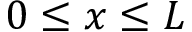<formula> <loc_0><loc_0><loc_500><loc_500>0 \leq x \leq L</formula> 